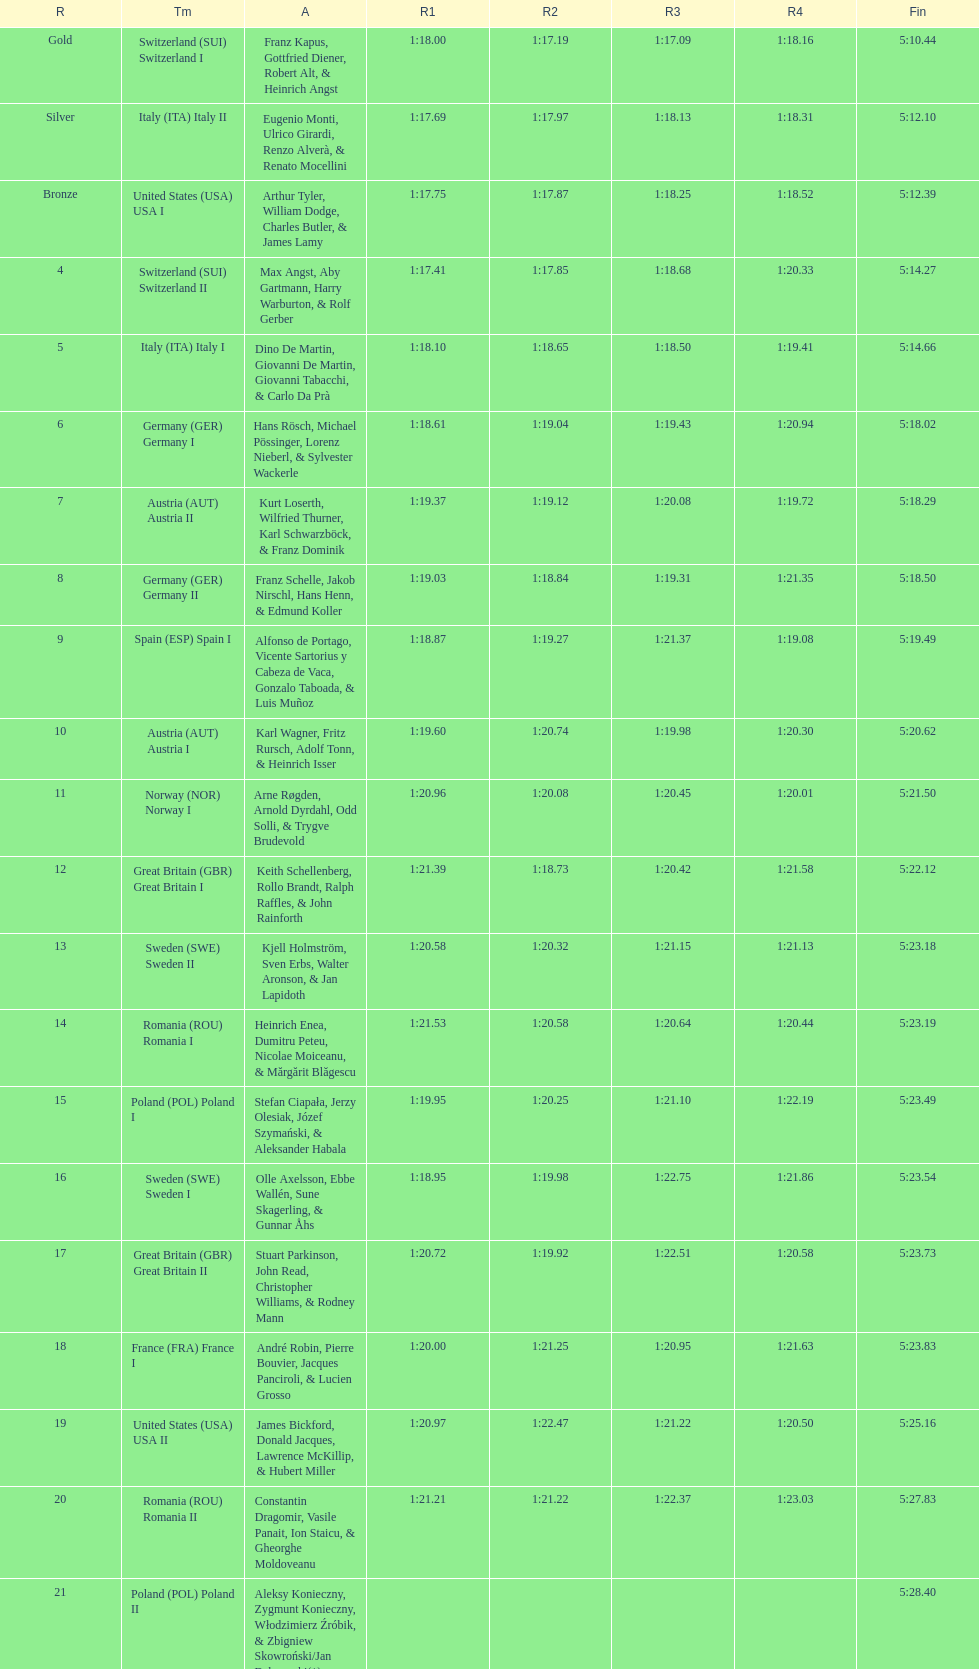What is the count of teams that germany had? 2. I'm looking to parse the entire table for insights. Could you assist me with that? {'header': ['R', 'Tm', 'A', 'R1', 'R2', 'R3', 'R4', 'Fin'], 'rows': [['Gold', 'Switzerland\xa0(SUI) Switzerland I', 'Franz Kapus, Gottfried Diener, Robert Alt, & Heinrich Angst', '1:18.00', '1:17.19', '1:17.09', '1:18.16', '5:10.44'], ['Silver', 'Italy\xa0(ITA) Italy II', 'Eugenio Monti, Ulrico Girardi, Renzo Alverà, & Renato Mocellini', '1:17.69', '1:17.97', '1:18.13', '1:18.31', '5:12.10'], ['Bronze', 'United States\xa0(USA) USA I', 'Arthur Tyler, William Dodge, Charles Butler, & James Lamy', '1:17.75', '1:17.87', '1:18.25', '1:18.52', '5:12.39'], ['4', 'Switzerland\xa0(SUI) Switzerland II', 'Max Angst, Aby Gartmann, Harry Warburton, & Rolf Gerber', '1:17.41', '1:17.85', '1:18.68', '1:20.33', '5:14.27'], ['5', 'Italy\xa0(ITA) Italy I', 'Dino De Martin, Giovanni De Martin, Giovanni Tabacchi, & Carlo Da Prà', '1:18.10', '1:18.65', '1:18.50', '1:19.41', '5:14.66'], ['6', 'Germany\xa0(GER) Germany I', 'Hans Rösch, Michael Pössinger, Lorenz Nieberl, & Sylvester Wackerle', '1:18.61', '1:19.04', '1:19.43', '1:20.94', '5:18.02'], ['7', 'Austria\xa0(AUT) Austria II', 'Kurt Loserth, Wilfried Thurner, Karl Schwarzböck, & Franz Dominik', '1:19.37', '1:19.12', '1:20.08', '1:19.72', '5:18.29'], ['8', 'Germany\xa0(GER) Germany II', 'Franz Schelle, Jakob Nirschl, Hans Henn, & Edmund Koller', '1:19.03', '1:18.84', '1:19.31', '1:21.35', '5:18.50'], ['9', 'Spain\xa0(ESP) Spain I', 'Alfonso de Portago, Vicente Sartorius y Cabeza de Vaca, Gonzalo Taboada, & Luis Muñoz', '1:18.87', '1:19.27', '1:21.37', '1:19.08', '5:19.49'], ['10', 'Austria\xa0(AUT) Austria I', 'Karl Wagner, Fritz Rursch, Adolf Tonn, & Heinrich Isser', '1:19.60', '1:20.74', '1:19.98', '1:20.30', '5:20.62'], ['11', 'Norway\xa0(NOR) Norway I', 'Arne Røgden, Arnold Dyrdahl, Odd Solli, & Trygve Brudevold', '1:20.96', '1:20.08', '1:20.45', '1:20.01', '5:21.50'], ['12', 'Great Britain\xa0(GBR) Great Britain I', 'Keith Schellenberg, Rollo Brandt, Ralph Raffles, & John Rainforth', '1:21.39', '1:18.73', '1:20.42', '1:21.58', '5:22.12'], ['13', 'Sweden\xa0(SWE) Sweden II', 'Kjell Holmström, Sven Erbs, Walter Aronson, & Jan Lapidoth', '1:20.58', '1:20.32', '1:21.15', '1:21.13', '5:23.18'], ['14', 'Romania\xa0(ROU) Romania I', 'Heinrich Enea, Dumitru Peteu, Nicolae Moiceanu, & Mărgărit Blăgescu', '1:21.53', '1:20.58', '1:20.64', '1:20.44', '5:23.19'], ['15', 'Poland\xa0(POL) Poland I', 'Stefan Ciapała, Jerzy Olesiak, Józef Szymański, & Aleksander Habala', '1:19.95', '1:20.25', '1:21.10', '1:22.19', '5:23.49'], ['16', 'Sweden\xa0(SWE) Sweden I', 'Olle Axelsson, Ebbe Wallén, Sune Skagerling, & Gunnar Åhs', '1:18.95', '1:19.98', '1:22.75', '1:21.86', '5:23.54'], ['17', 'Great Britain\xa0(GBR) Great Britain II', 'Stuart Parkinson, John Read, Christopher Williams, & Rodney Mann', '1:20.72', '1:19.92', '1:22.51', '1:20.58', '5:23.73'], ['18', 'France\xa0(FRA) France I', 'André Robin, Pierre Bouvier, Jacques Panciroli, & Lucien Grosso', '1:20.00', '1:21.25', '1:20.95', '1:21.63', '5:23.83'], ['19', 'United States\xa0(USA) USA II', 'James Bickford, Donald Jacques, Lawrence McKillip, & Hubert Miller', '1:20.97', '1:22.47', '1:21.22', '1:20.50', '5:25.16'], ['20', 'Romania\xa0(ROU) Romania II', 'Constantin Dragomir, Vasile Panait, Ion Staicu, & Gheorghe Moldoveanu', '1:21.21', '1:21.22', '1:22.37', '1:23.03', '5:27.83'], ['21', 'Poland\xa0(POL) Poland II', 'Aleksy Konieczny, Zygmunt Konieczny, Włodzimierz Źróbik, & Zbigniew Skowroński/Jan Dąbrowski(*)', '', '', '', '', '5:28.40']]} 